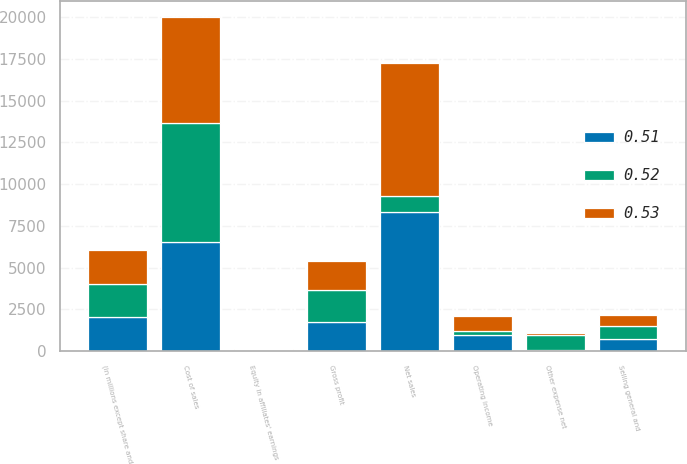Convert chart to OTSL. <chart><loc_0><loc_0><loc_500><loc_500><stacked_bar_chart><ecel><fcel>(in millions except share and<fcel>Net sales<fcel>Cost of sales<fcel>Gross profit<fcel>Selling general and<fcel>Other expense net<fcel>Operating income<fcel>Equity in affiliates' earnings<nl><fcel>0.52<fcel>2016<fcel>963.7<fcel>7137.9<fcel>1933.1<fcel>817.5<fcel>889.7<fcel>225.9<fcel>42.9<nl><fcel>0.53<fcel>2015<fcel>8023.2<fcel>6320.1<fcel>1703.1<fcel>662<fcel>101.4<fcel>939.7<fcel>40<nl><fcel>0.51<fcel>2014<fcel>8305.1<fcel>6548.7<fcel>1756.4<fcel>698.9<fcel>93.8<fcel>963.7<fcel>47.3<nl></chart> 